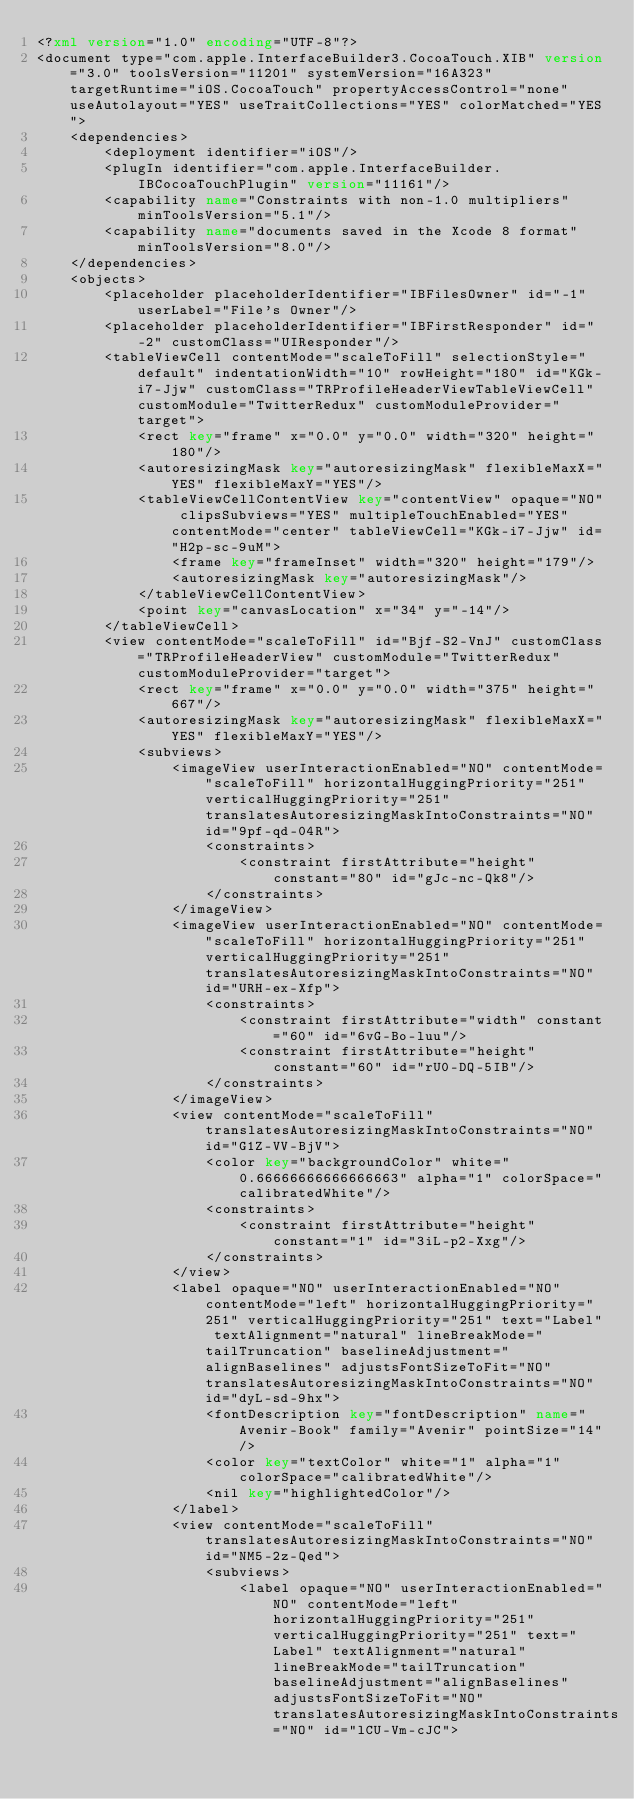<code> <loc_0><loc_0><loc_500><loc_500><_XML_><?xml version="1.0" encoding="UTF-8"?>
<document type="com.apple.InterfaceBuilder3.CocoaTouch.XIB" version="3.0" toolsVersion="11201" systemVersion="16A323" targetRuntime="iOS.CocoaTouch" propertyAccessControl="none" useAutolayout="YES" useTraitCollections="YES" colorMatched="YES">
    <dependencies>
        <deployment identifier="iOS"/>
        <plugIn identifier="com.apple.InterfaceBuilder.IBCocoaTouchPlugin" version="11161"/>
        <capability name="Constraints with non-1.0 multipliers" minToolsVersion="5.1"/>
        <capability name="documents saved in the Xcode 8 format" minToolsVersion="8.0"/>
    </dependencies>
    <objects>
        <placeholder placeholderIdentifier="IBFilesOwner" id="-1" userLabel="File's Owner"/>
        <placeholder placeholderIdentifier="IBFirstResponder" id="-2" customClass="UIResponder"/>
        <tableViewCell contentMode="scaleToFill" selectionStyle="default" indentationWidth="10" rowHeight="180" id="KGk-i7-Jjw" customClass="TRProfileHeaderViewTableViewCell" customModule="TwitterRedux" customModuleProvider="target">
            <rect key="frame" x="0.0" y="0.0" width="320" height="180"/>
            <autoresizingMask key="autoresizingMask" flexibleMaxX="YES" flexibleMaxY="YES"/>
            <tableViewCellContentView key="contentView" opaque="NO" clipsSubviews="YES" multipleTouchEnabled="YES" contentMode="center" tableViewCell="KGk-i7-Jjw" id="H2p-sc-9uM">
                <frame key="frameInset" width="320" height="179"/>
                <autoresizingMask key="autoresizingMask"/>
            </tableViewCellContentView>
            <point key="canvasLocation" x="34" y="-14"/>
        </tableViewCell>
        <view contentMode="scaleToFill" id="Bjf-S2-VnJ" customClass="TRProfileHeaderView" customModule="TwitterRedux" customModuleProvider="target">
            <rect key="frame" x="0.0" y="0.0" width="375" height="667"/>
            <autoresizingMask key="autoresizingMask" flexibleMaxX="YES" flexibleMaxY="YES"/>
            <subviews>
                <imageView userInteractionEnabled="NO" contentMode="scaleToFill" horizontalHuggingPriority="251" verticalHuggingPriority="251" translatesAutoresizingMaskIntoConstraints="NO" id="9pf-qd-04R">
                    <constraints>
                        <constraint firstAttribute="height" constant="80" id="gJc-nc-Qk8"/>
                    </constraints>
                </imageView>
                <imageView userInteractionEnabled="NO" contentMode="scaleToFill" horizontalHuggingPriority="251" verticalHuggingPriority="251" translatesAutoresizingMaskIntoConstraints="NO" id="URH-ex-Xfp">
                    <constraints>
                        <constraint firstAttribute="width" constant="60" id="6vG-Bo-luu"/>
                        <constraint firstAttribute="height" constant="60" id="rU0-DQ-5IB"/>
                    </constraints>
                </imageView>
                <view contentMode="scaleToFill" translatesAutoresizingMaskIntoConstraints="NO" id="G1Z-VV-BjV">
                    <color key="backgroundColor" white="0.66666666666666663" alpha="1" colorSpace="calibratedWhite"/>
                    <constraints>
                        <constraint firstAttribute="height" constant="1" id="3iL-p2-Xxg"/>
                    </constraints>
                </view>
                <label opaque="NO" userInteractionEnabled="NO" contentMode="left" horizontalHuggingPriority="251" verticalHuggingPriority="251" text="Label" textAlignment="natural" lineBreakMode="tailTruncation" baselineAdjustment="alignBaselines" adjustsFontSizeToFit="NO" translatesAutoresizingMaskIntoConstraints="NO" id="dyL-sd-9hx">
                    <fontDescription key="fontDescription" name="Avenir-Book" family="Avenir" pointSize="14"/>
                    <color key="textColor" white="1" alpha="1" colorSpace="calibratedWhite"/>
                    <nil key="highlightedColor"/>
                </label>
                <view contentMode="scaleToFill" translatesAutoresizingMaskIntoConstraints="NO" id="NM5-2z-Qed">
                    <subviews>
                        <label opaque="NO" userInteractionEnabled="NO" contentMode="left" horizontalHuggingPriority="251" verticalHuggingPriority="251" text="Label" textAlignment="natural" lineBreakMode="tailTruncation" baselineAdjustment="alignBaselines" adjustsFontSizeToFit="NO" translatesAutoresizingMaskIntoConstraints="NO" id="lCU-Vm-cJC"></code> 